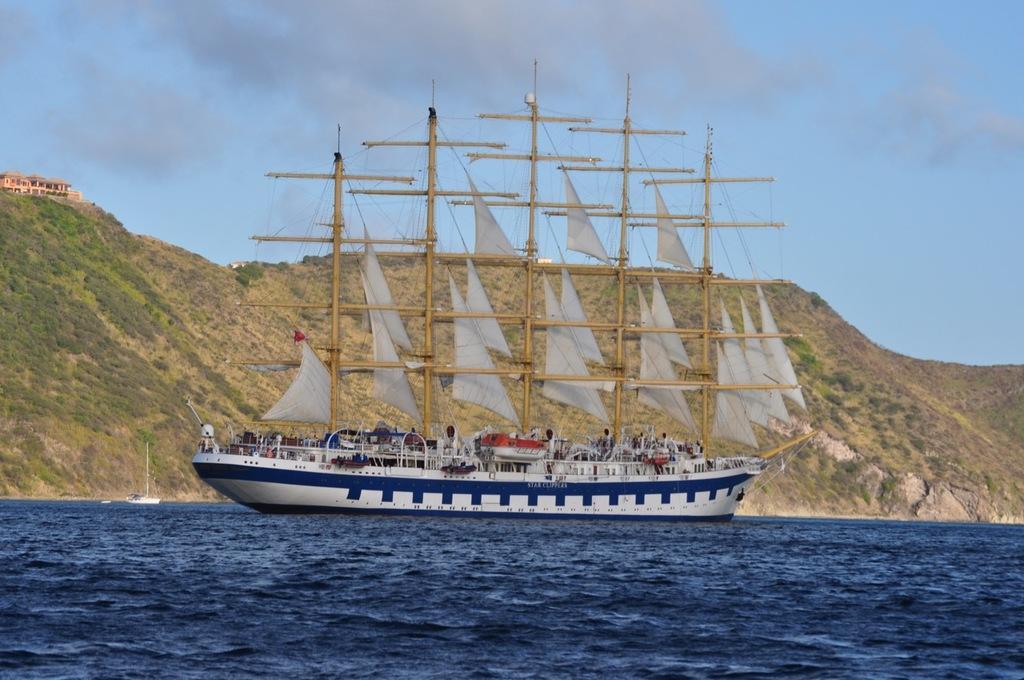How would you summarize this image in a sentence or two? In the middle of this image, there is a ship in white and blue color combination on the water. Beside this ship, there is a white color boat on the water. In the background, there are trees, buildings and plants on a mountain and there are clouds in the blue sky. 